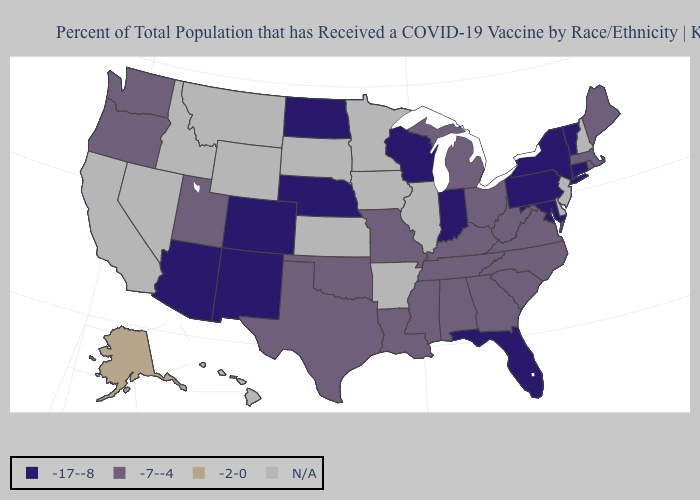Name the states that have a value in the range -7--4?
Give a very brief answer. Alabama, Georgia, Kentucky, Louisiana, Maine, Massachusetts, Michigan, Mississippi, Missouri, North Carolina, Ohio, Oklahoma, Oregon, Rhode Island, South Carolina, Tennessee, Texas, Utah, Virginia, Washington, West Virginia. Does Vermont have the lowest value in the USA?
Write a very short answer. Yes. What is the value of Wyoming?
Short answer required. N/A. Name the states that have a value in the range N/A?
Keep it brief. Arkansas, California, Delaware, Hawaii, Idaho, Illinois, Iowa, Kansas, Minnesota, Montana, Nevada, New Hampshire, New Jersey, South Dakota, Wyoming. Name the states that have a value in the range -7--4?
Answer briefly. Alabama, Georgia, Kentucky, Louisiana, Maine, Massachusetts, Michigan, Mississippi, Missouri, North Carolina, Ohio, Oklahoma, Oregon, Rhode Island, South Carolina, Tennessee, Texas, Utah, Virginia, Washington, West Virginia. Does South Carolina have the highest value in the USA?
Short answer required. No. What is the value of South Carolina?
Write a very short answer. -7--4. What is the highest value in the MidWest ?
Quick response, please. -7--4. What is the value of Nevada?
Be succinct. N/A. What is the highest value in the USA?
Be succinct. -2-0. Name the states that have a value in the range N/A?
Short answer required. Arkansas, California, Delaware, Hawaii, Idaho, Illinois, Iowa, Kansas, Minnesota, Montana, Nevada, New Hampshire, New Jersey, South Dakota, Wyoming. Which states hav the highest value in the South?
Short answer required. Alabama, Georgia, Kentucky, Louisiana, Mississippi, North Carolina, Oklahoma, South Carolina, Tennessee, Texas, Virginia, West Virginia. Does Alabama have the highest value in the USA?
Short answer required. No. Which states have the lowest value in the USA?
Keep it brief. Arizona, Colorado, Connecticut, Florida, Indiana, Maryland, Nebraska, New Mexico, New York, North Dakota, Pennsylvania, Vermont, Wisconsin. 